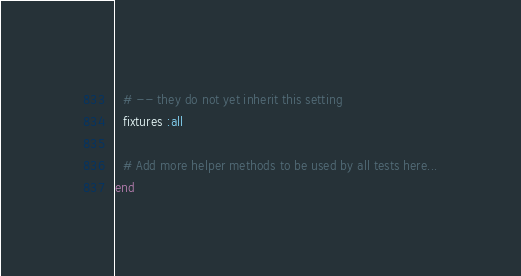<code> <loc_0><loc_0><loc_500><loc_500><_Ruby_>  # -- they do not yet inherit this setting
  fixtures :all

  # Add more helper methods to be used by all tests here...
end
</code> 